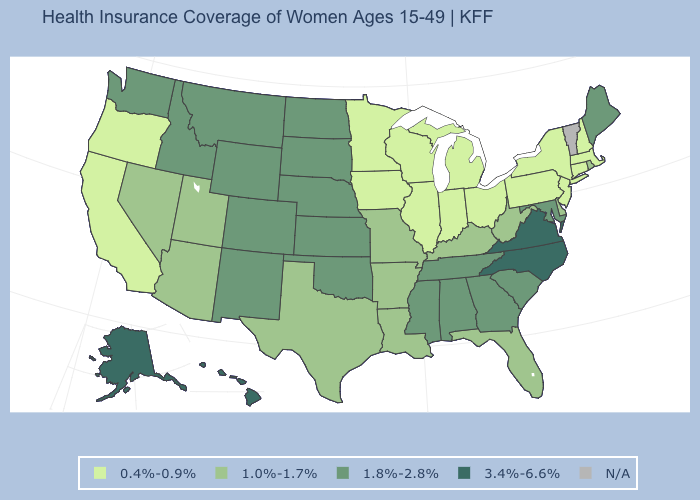Does Kansas have the highest value in the MidWest?
Answer briefly. Yes. Among the states that border Michigan , which have the highest value?
Give a very brief answer. Indiana, Ohio, Wisconsin. Does Virginia have the highest value in the USA?
Answer briefly. Yes. Name the states that have a value in the range 1.8%-2.8%?
Answer briefly. Alabama, Colorado, Georgia, Idaho, Kansas, Maine, Maryland, Mississippi, Montana, Nebraska, New Mexico, North Dakota, Oklahoma, South Carolina, South Dakota, Tennessee, Washington, Wyoming. Does the first symbol in the legend represent the smallest category?
Give a very brief answer. Yes. What is the lowest value in states that border Massachusetts?
Concise answer only. 0.4%-0.9%. Name the states that have a value in the range 1.8%-2.8%?
Answer briefly. Alabama, Colorado, Georgia, Idaho, Kansas, Maine, Maryland, Mississippi, Montana, Nebraska, New Mexico, North Dakota, Oklahoma, South Carolina, South Dakota, Tennessee, Washington, Wyoming. Which states have the highest value in the USA?
Write a very short answer. Alaska, Hawaii, North Carolina, Virginia. Which states have the lowest value in the South?
Give a very brief answer. Arkansas, Delaware, Florida, Kentucky, Louisiana, Texas, West Virginia. Does Alaska have the highest value in the USA?
Short answer required. Yes. What is the value of Oklahoma?
Concise answer only. 1.8%-2.8%. Which states hav the highest value in the Northeast?
Answer briefly. Maine. 